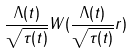Convert formula to latex. <formula><loc_0><loc_0><loc_500><loc_500>\frac { \Lambda ( t ) } { \sqrt { \tau ( t ) } } W ( \frac { \Lambda ( t ) } { \sqrt { \tau ( t ) } } r )</formula> 